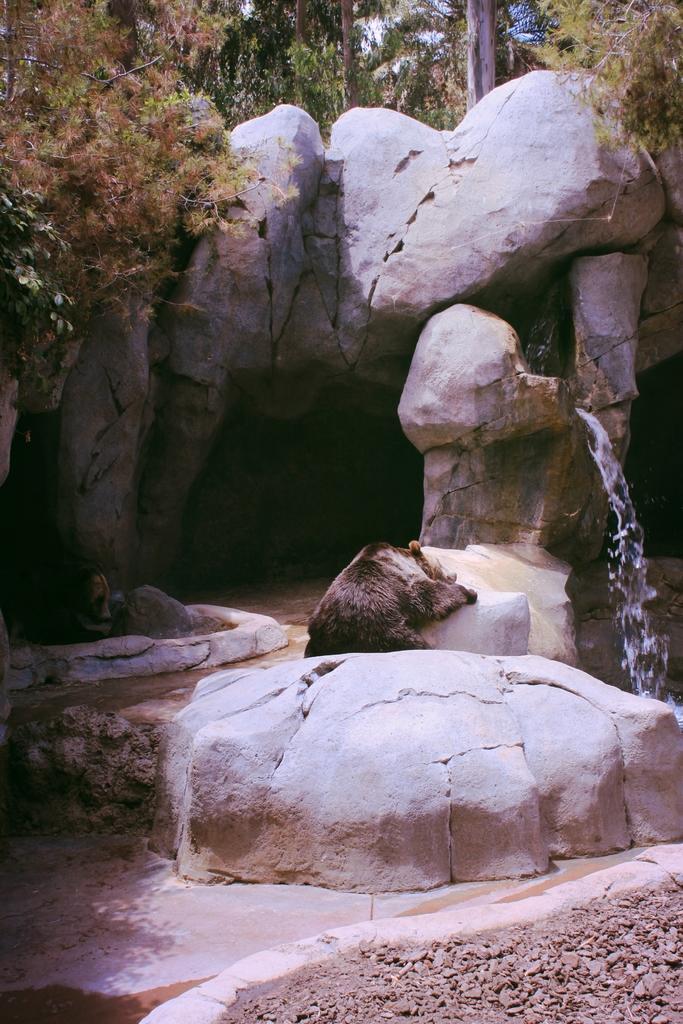Could you give a brief overview of what you see in this image? In this image, there are two bears. I can see water falling from the rocks. In the background, there are trees. 